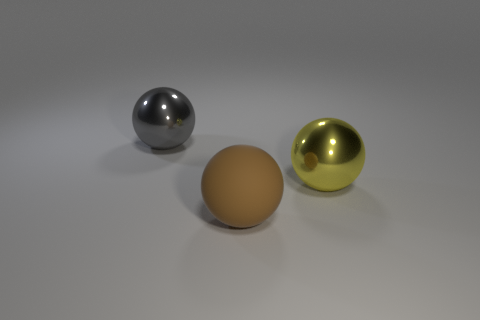Add 3 brown rubber spheres. How many objects exist? 6 Subtract 0 blue cylinders. How many objects are left? 3 Subtract all big yellow things. Subtract all big yellow spheres. How many objects are left? 1 Add 3 large brown objects. How many large brown objects are left? 4 Add 2 gray metallic objects. How many gray metallic objects exist? 3 